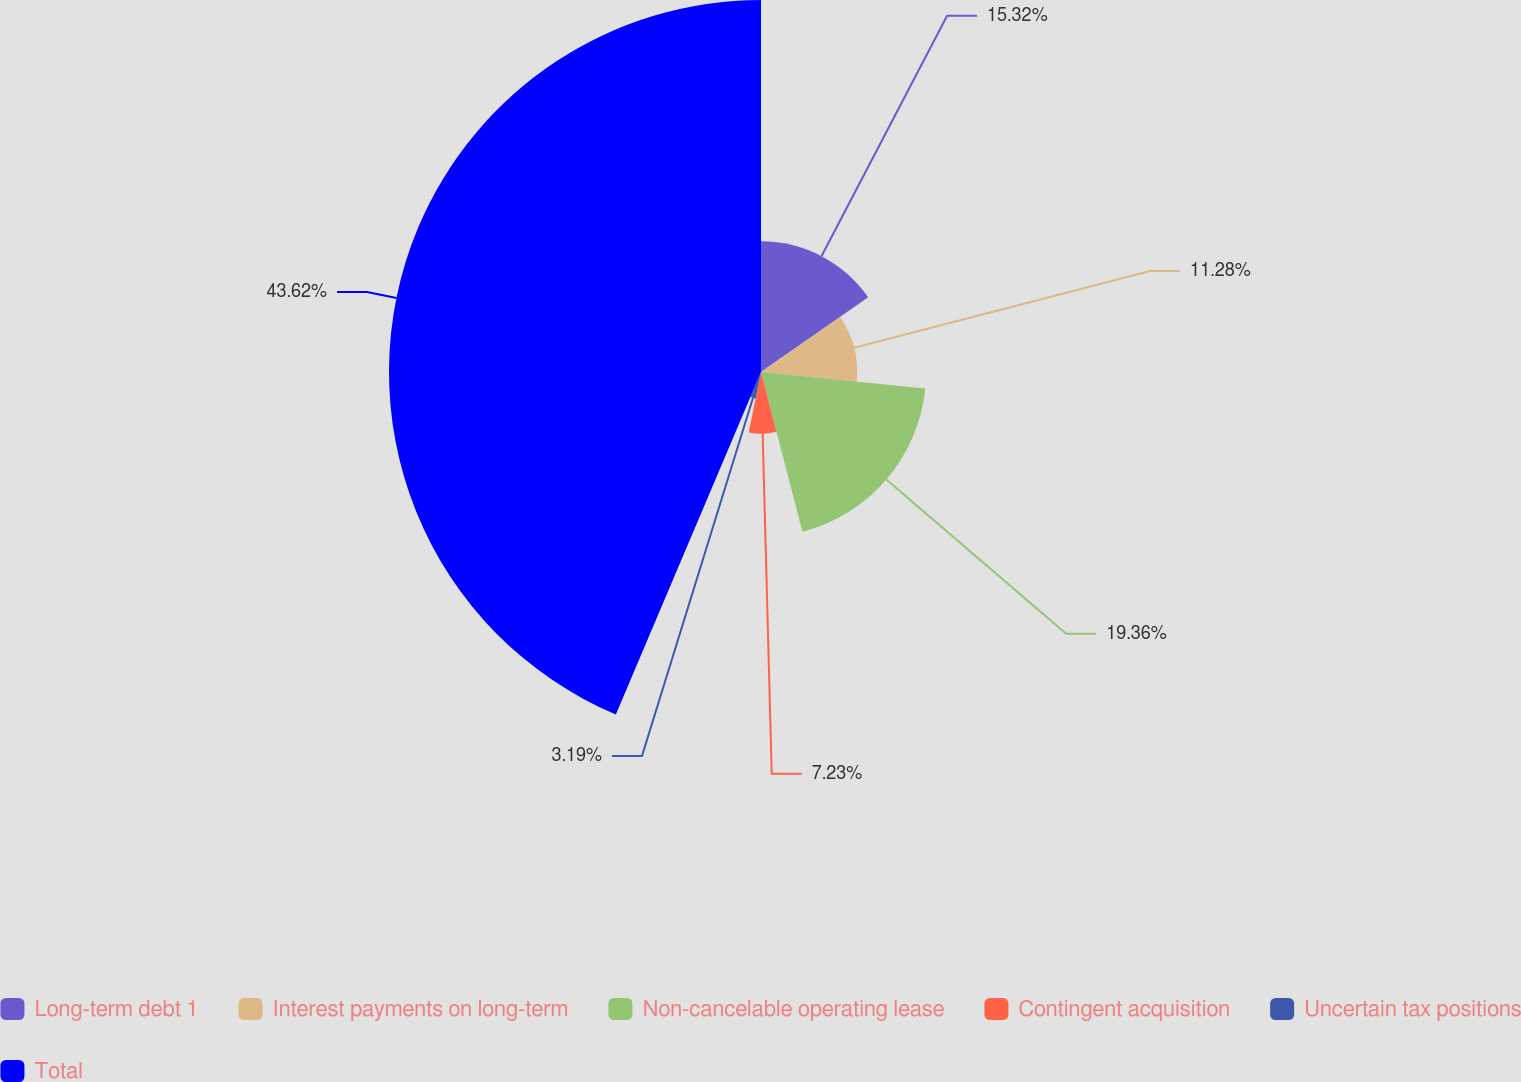<chart> <loc_0><loc_0><loc_500><loc_500><pie_chart><fcel>Long-term debt 1<fcel>Interest payments on long-term<fcel>Non-cancelable operating lease<fcel>Contingent acquisition<fcel>Uncertain tax positions<fcel>Total<nl><fcel>15.32%<fcel>11.28%<fcel>19.36%<fcel>7.23%<fcel>3.19%<fcel>43.62%<nl></chart> 